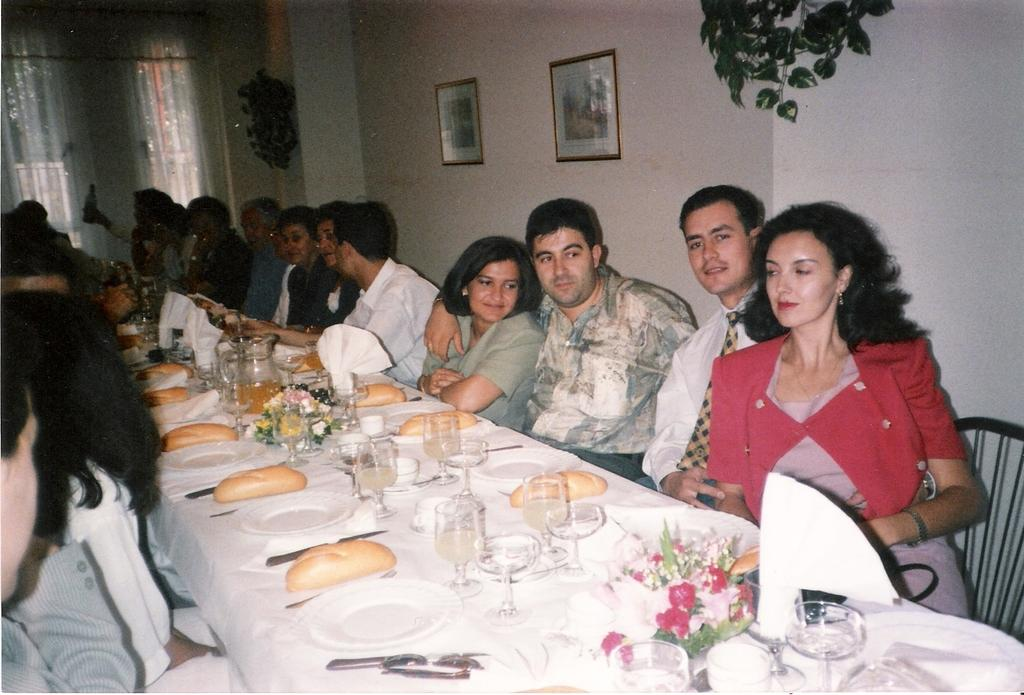What are the people in the image doing? The people in the image are sitting on chairs. What can be seen on the table in the image? There are glasses, plates, house plants, and other objects on the table. Are there any decorations on the wall in the image? Yes, there are frames on the wall. What type of floor can be seen in the image? There is no information about the floor in the image, as the focus is on the people, table, and wall. Is there a fire visible in the image? No, there is no fire present in the image. Can you see a train in the image? No, there is no train present in the image. 